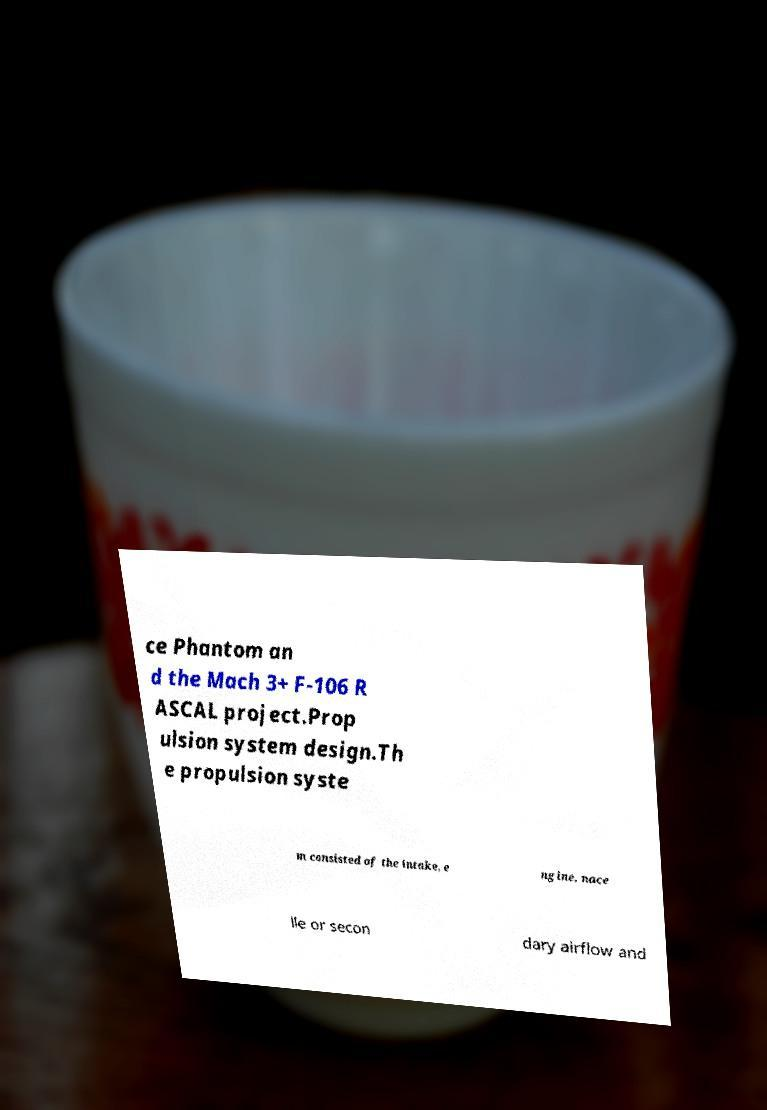Please identify and transcribe the text found in this image. ce Phantom an d the Mach 3+ F-106 R ASCAL project.Prop ulsion system design.Th e propulsion syste m consisted of the intake, e ngine, nace lle or secon dary airflow and 